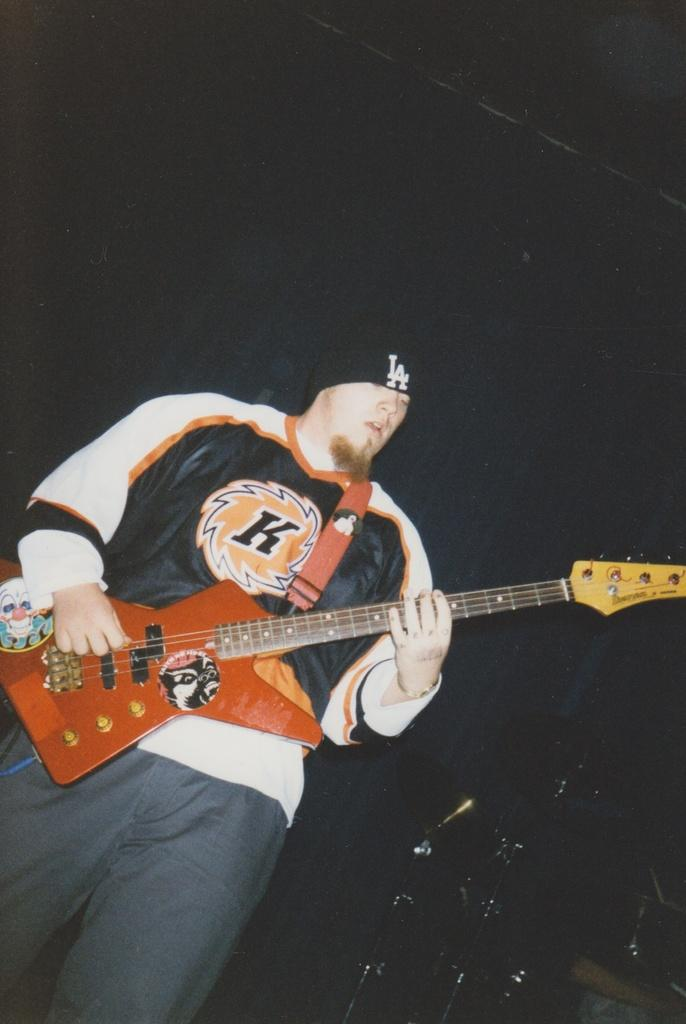What is the man in the image doing? The man is playing a guitar. What is the man wearing in the image? The man is wearing a t-shirt. Can you see any snow falling in the image? There is no snow present in the image. Is there a squirrel visible in the image? There is no squirrel present in the image. 